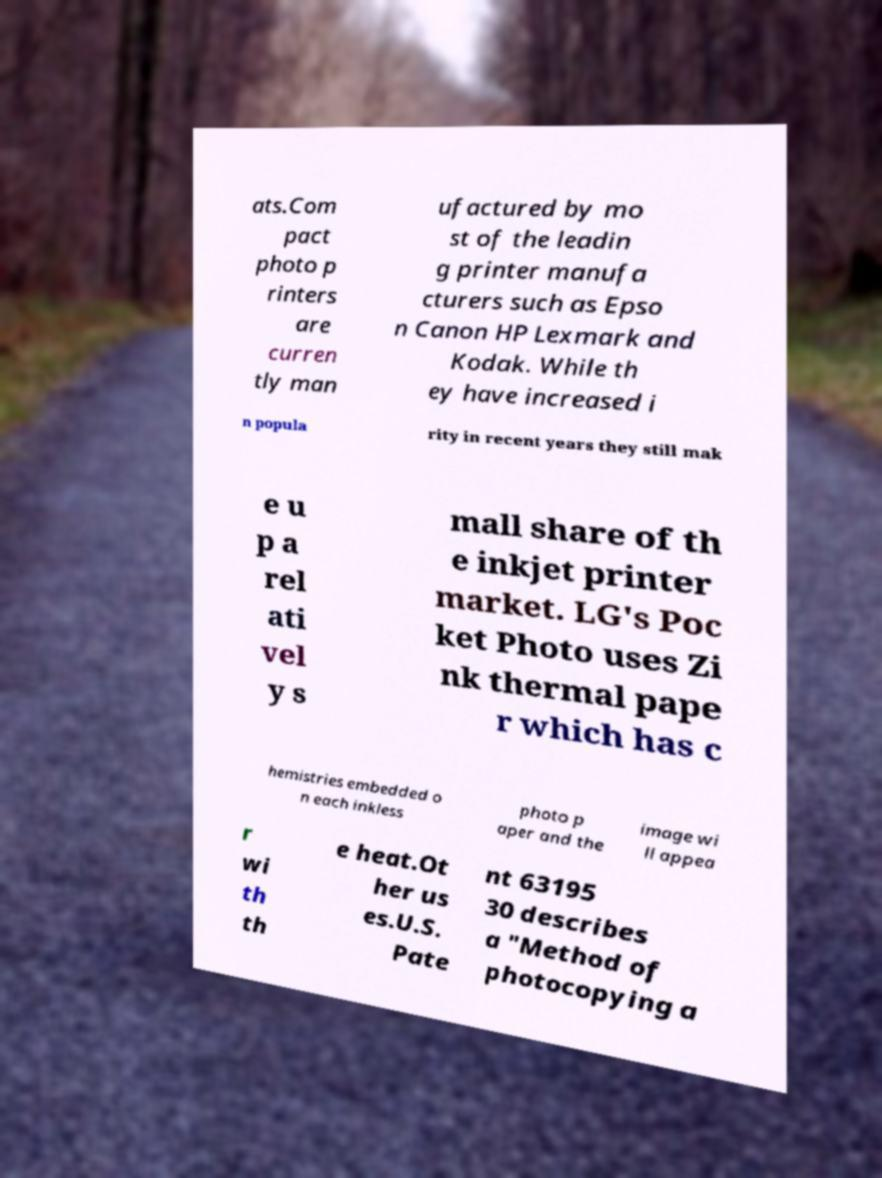Could you extract and type out the text from this image? ats.Com pact photo p rinters are curren tly man ufactured by mo st of the leadin g printer manufa cturers such as Epso n Canon HP Lexmark and Kodak. While th ey have increased i n popula rity in recent years they still mak e u p a rel ati vel y s mall share of th e inkjet printer market. LG's Poc ket Photo uses Zi nk thermal pape r which has c hemistries embedded o n each inkless photo p aper and the image wi ll appea r wi th th e heat.Ot her us es.U.S. Pate nt 63195 30 describes a "Method of photocopying a 